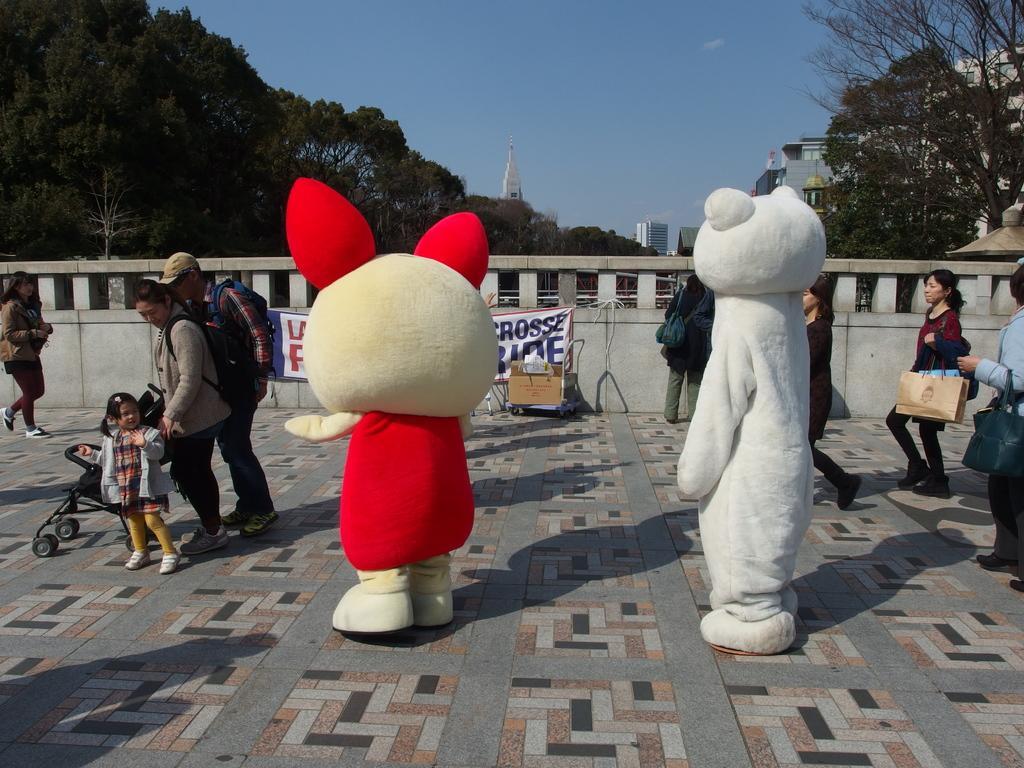How would you summarize this image in a sentence or two? In this picture we can see a group of people where some are standing and some are walking on the ground, stroller, banner, box, fence, trees and in the background we can see buildings, sky. 